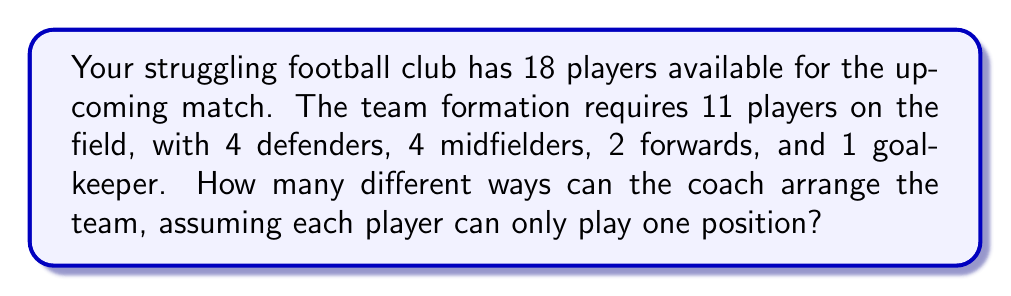Solve this math problem. Let's approach this step-by-step using the multiplication principle of counting:

1) First, let's choose the goalkeeper:
   There are 18 players to choose from for this position.
   $18$ ways to choose 1 goalkeeper

2) Next, we choose 4 defenders from the remaining 17 players:
   This can be done in $\binom{17}{4}$ ways

3) Then, we choose 4 midfielders from the remaining 13 players:
   This can be done in $\binom{13}{4}$ ways

4) Finally, we choose 2 forwards from the remaining 9 players:
   This can be done in $\binom{9}{2}$ ways

5) By the multiplication principle, the total number of ways to arrange the team is:

   $$18 \cdot \binom{17}{4} \cdot \binom{13}{4} \cdot \binom{9}{2}$$

6) Let's calculate each combination:
   $\binom{17}{4} = 2380$
   $\binom{13}{4} = 715$
   $\binom{9}{2} = 36$

7) Multiplying these together:

   $$18 \cdot 2380 \cdot 715 \cdot 36 = 1,101,729,600$$

Therefore, there are 1,101,729,600 different ways the coach can arrange the team.
Answer: 1,101,729,600 